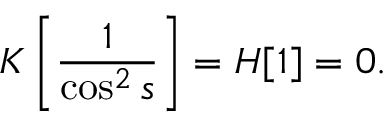Convert formula to latex. <formula><loc_0><loc_0><loc_500><loc_500>K \left [ \frac { 1 } { \cos ^ { 2 } s } \right ] = H [ 1 ] = 0 .</formula> 